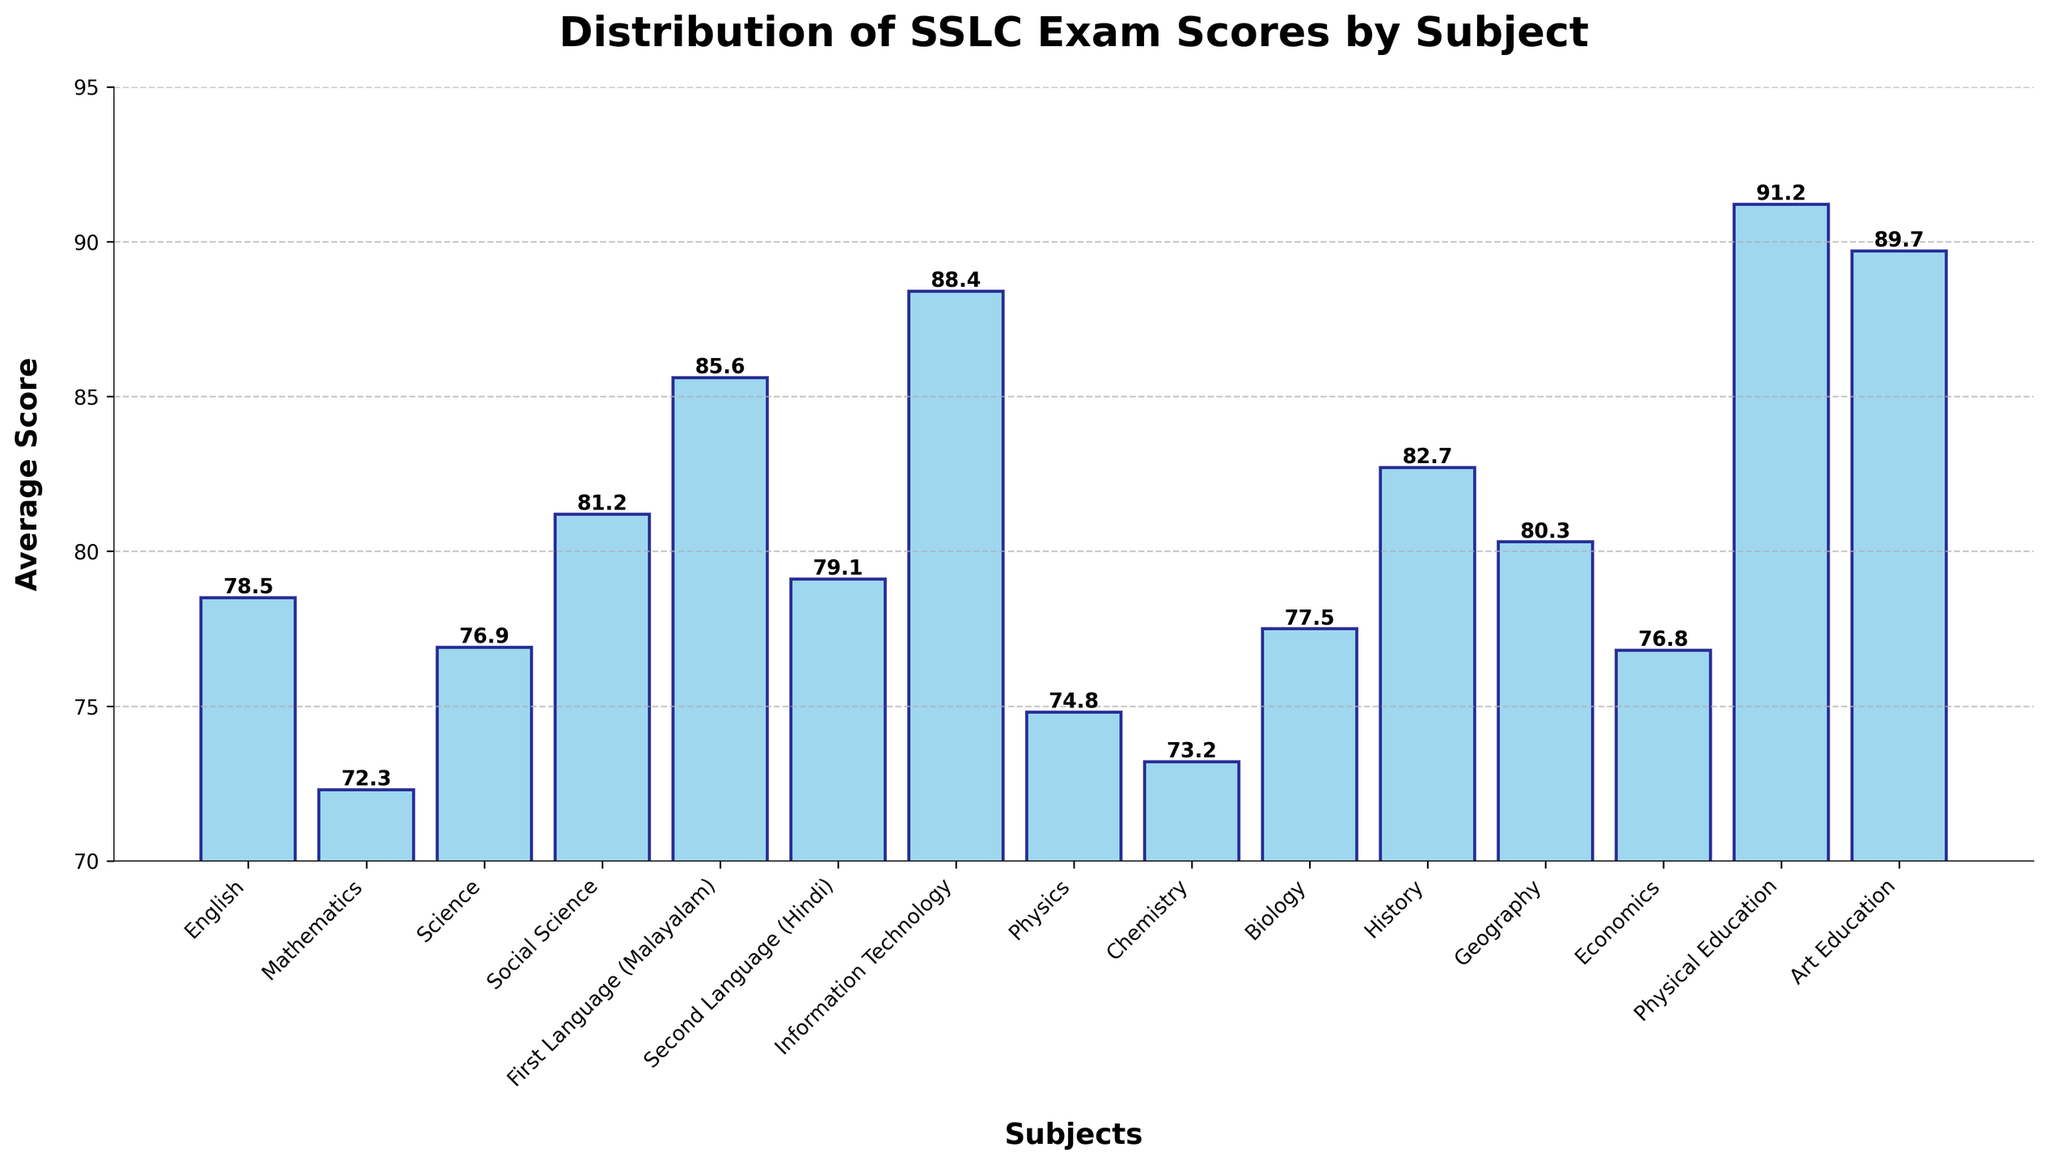What is the subject with the highest average score? The subject with the highest average score can be identified by observing the height of the bars. The tallest bar represents the subject with the highest score. In this case, the bar for Physical Education is the tallest with an average score of 91.2.
Answer: Physical Education What is the difference between the average score of Chemistry and Physics? To find the difference, observe the heights of the bars for Chemistry and Physics and then calculate the difference between the two scores. The average score for Physics is 74.8 and for Chemistry is 73.2. So, the difference is 74.8 - 73.2 = 1.6.
Answer: 1.6 Which subjects have average scores above 80? To determine which subjects have average scores above 80, scan the heights of the bars and note the subjects that surpass the 80 mark on the y-axis. The subjects that meet this criterion are Social Science (81.2), Second Language (Hindi) (79.1), History (82.7), Geography (80.3), and Art Education (89.7).
Answer: Social Science, History, Geography, Art Education What is the combined average score of Mathematics, Science, and Biology? Sum the average scores of Mathematics (72.3), Science (76.9), and Biology (77.5). The combined average score is 72.3 + 76.9 + 77.5 = 226.7.
Answer: 226.7 Which subject has the lowest average score, and what is that score? The subject with the lowest average score can be identified by observing the shortest bar. The shortest bar represents Mathematics with an average score of 72.3.
Answer: Mathematics, 72.3 How many subjects have scores between 75 and 85? Count the number of bars with heights corresponding to average scores between 75 and 85. These include Science (76.9), Second Language (Hindi) (79.1), Physics (74.8), Chemistry (73.2), Biology (77.5), Economics (76.8), and Geography (80.3) for a total of seven subjects.
Answer: 7 Which subject just exceeds an average score of 80? Identify the bar that has an average score slightly above 80. Geography has an average score of 80.3, which is just above 80.
Answer: Geography What is the average score for Art Education and Information Technology together? Sum the average scores of Art Education (89.7) and Information Technology (88.4), then divide by 2 to get the average: (89.7 + 88.4) / 2 = 178.1 / 2 = 89.05.
Answer: 89.05 Which subject's average score is closest to the y-axis value of 80? Observe the bars near the 80 mark and find the one closest. Geography with 80.3 is the closest to 80.
Answer: Geography 